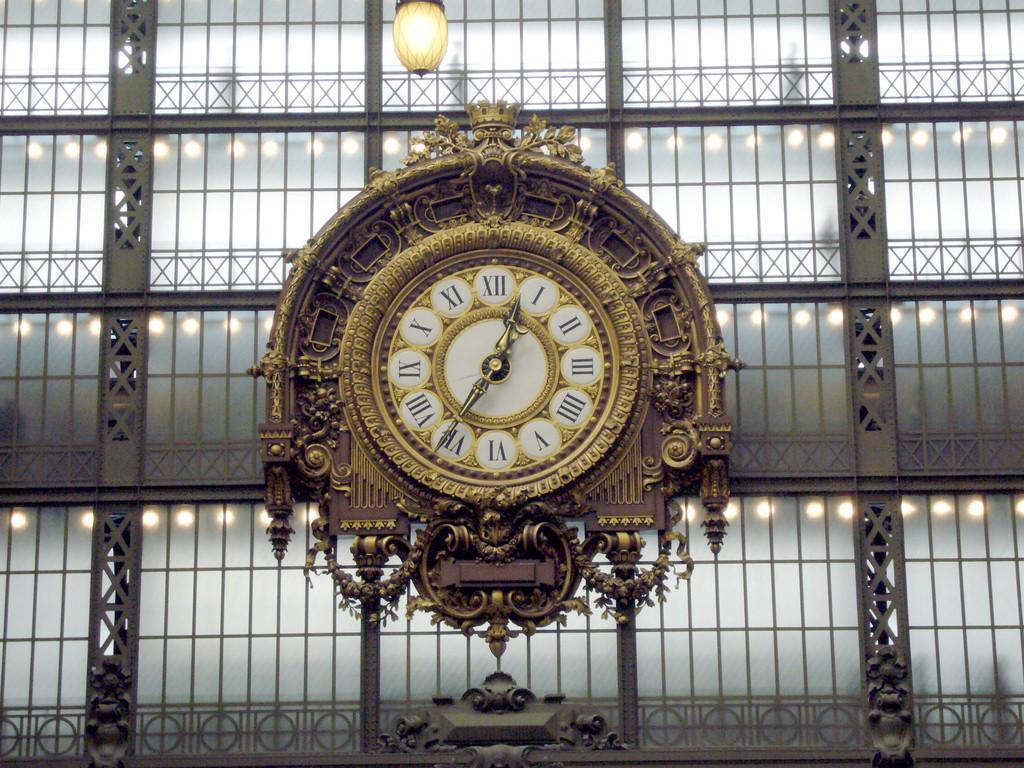Describe this image in one or two sentences. In this picture I can see there is a clock and it has a seconds hand, minute hand and hour hand. It has a brown color frame and there is a golden color design on it and in the backdrop I can see there is a wall and it has some lights and the wall has glass windows and the wall is in grey color. 